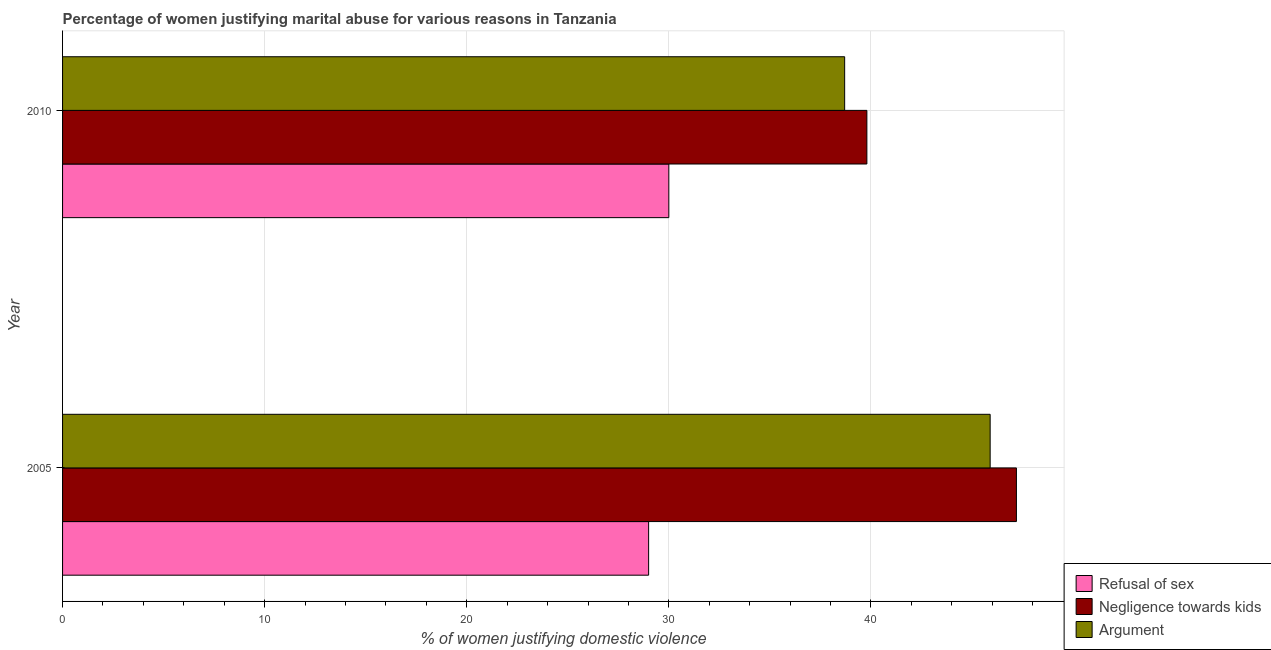Are the number of bars per tick equal to the number of legend labels?
Your answer should be compact. Yes. How many bars are there on the 2nd tick from the bottom?
Offer a very short reply. 3. What is the label of the 1st group of bars from the top?
Ensure brevity in your answer.  2010. In how many cases, is the number of bars for a given year not equal to the number of legend labels?
Keep it short and to the point. 0. What is the percentage of women justifying domestic violence due to refusal of sex in 2005?
Make the answer very short. 29. Across all years, what is the maximum percentage of women justifying domestic violence due to refusal of sex?
Provide a succinct answer. 30. Across all years, what is the minimum percentage of women justifying domestic violence due to refusal of sex?
Provide a short and direct response. 29. In which year was the percentage of women justifying domestic violence due to refusal of sex maximum?
Provide a succinct answer. 2010. What is the total percentage of women justifying domestic violence due to arguments in the graph?
Your answer should be compact. 84.6. What is the difference between the percentage of women justifying domestic violence due to refusal of sex in 2005 and that in 2010?
Provide a short and direct response. -1. What is the average percentage of women justifying domestic violence due to refusal of sex per year?
Your answer should be very brief. 29.5. In the year 2010, what is the difference between the percentage of women justifying domestic violence due to refusal of sex and percentage of women justifying domestic violence due to arguments?
Keep it short and to the point. -8.7. What is the ratio of the percentage of women justifying domestic violence due to arguments in 2005 to that in 2010?
Offer a terse response. 1.19. Is the percentage of women justifying domestic violence due to arguments in 2005 less than that in 2010?
Make the answer very short. No. Is the difference between the percentage of women justifying domestic violence due to refusal of sex in 2005 and 2010 greater than the difference between the percentage of women justifying domestic violence due to arguments in 2005 and 2010?
Provide a short and direct response. No. In how many years, is the percentage of women justifying domestic violence due to refusal of sex greater than the average percentage of women justifying domestic violence due to refusal of sex taken over all years?
Make the answer very short. 1. What does the 1st bar from the top in 2010 represents?
Provide a short and direct response. Argument. What does the 3rd bar from the bottom in 2005 represents?
Offer a very short reply. Argument. Is it the case that in every year, the sum of the percentage of women justifying domestic violence due to refusal of sex and percentage of women justifying domestic violence due to negligence towards kids is greater than the percentage of women justifying domestic violence due to arguments?
Give a very brief answer. Yes. Are all the bars in the graph horizontal?
Offer a very short reply. Yes. How many years are there in the graph?
Make the answer very short. 2. Does the graph contain any zero values?
Offer a terse response. No. Does the graph contain grids?
Give a very brief answer. Yes. Where does the legend appear in the graph?
Offer a very short reply. Bottom right. How many legend labels are there?
Offer a terse response. 3. What is the title of the graph?
Offer a very short reply. Percentage of women justifying marital abuse for various reasons in Tanzania. What is the label or title of the X-axis?
Your answer should be compact. % of women justifying domestic violence. What is the % of women justifying domestic violence in Refusal of sex in 2005?
Provide a short and direct response. 29. What is the % of women justifying domestic violence in Negligence towards kids in 2005?
Offer a very short reply. 47.2. What is the % of women justifying domestic violence in Argument in 2005?
Your answer should be compact. 45.9. What is the % of women justifying domestic violence in Refusal of sex in 2010?
Offer a very short reply. 30. What is the % of women justifying domestic violence in Negligence towards kids in 2010?
Offer a very short reply. 39.8. What is the % of women justifying domestic violence of Argument in 2010?
Your answer should be very brief. 38.7. Across all years, what is the maximum % of women justifying domestic violence of Refusal of sex?
Give a very brief answer. 30. Across all years, what is the maximum % of women justifying domestic violence in Negligence towards kids?
Your response must be concise. 47.2. Across all years, what is the maximum % of women justifying domestic violence of Argument?
Offer a terse response. 45.9. Across all years, what is the minimum % of women justifying domestic violence of Negligence towards kids?
Ensure brevity in your answer.  39.8. Across all years, what is the minimum % of women justifying domestic violence in Argument?
Your response must be concise. 38.7. What is the total % of women justifying domestic violence in Refusal of sex in the graph?
Offer a very short reply. 59. What is the total % of women justifying domestic violence of Negligence towards kids in the graph?
Keep it short and to the point. 87. What is the total % of women justifying domestic violence of Argument in the graph?
Provide a short and direct response. 84.6. What is the difference between the % of women justifying domestic violence in Argument in 2005 and that in 2010?
Your answer should be compact. 7.2. What is the difference between the % of women justifying domestic violence in Negligence towards kids in 2005 and the % of women justifying domestic violence in Argument in 2010?
Provide a short and direct response. 8.5. What is the average % of women justifying domestic violence of Refusal of sex per year?
Your response must be concise. 29.5. What is the average % of women justifying domestic violence of Negligence towards kids per year?
Offer a very short reply. 43.5. What is the average % of women justifying domestic violence in Argument per year?
Make the answer very short. 42.3. In the year 2005, what is the difference between the % of women justifying domestic violence of Refusal of sex and % of women justifying domestic violence of Negligence towards kids?
Provide a succinct answer. -18.2. In the year 2005, what is the difference between the % of women justifying domestic violence in Refusal of sex and % of women justifying domestic violence in Argument?
Keep it short and to the point. -16.9. In the year 2010, what is the difference between the % of women justifying domestic violence in Refusal of sex and % of women justifying domestic violence in Negligence towards kids?
Offer a very short reply. -9.8. What is the ratio of the % of women justifying domestic violence in Refusal of sex in 2005 to that in 2010?
Offer a very short reply. 0.97. What is the ratio of the % of women justifying domestic violence of Negligence towards kids in 2005 to that in 2010?
Offer a terse response. 1.19. What is the ratio of the % of women justifying domestic violence of Argument in 2005 to that in 2010?
Your answer should be very brief. 1.19. What is the difference between the highest and the second highest % of women justifying domestic violence of Refusal of sex?
Your answer should be compact. 1. What is the difference between the highest and the second highest % of women justifying domestic violence of Negligence towards kids?
Ensure brevity in your answer.  7.4. What is the difference between the highest and the second highest % of women justifying domestic violence of Argument?
Offer a very short reply. 7.2. What is the difference between the highest and the lowest % of women justifying domestic violence in Negligence towards kids?
Your answer should be compact. 7.4. 